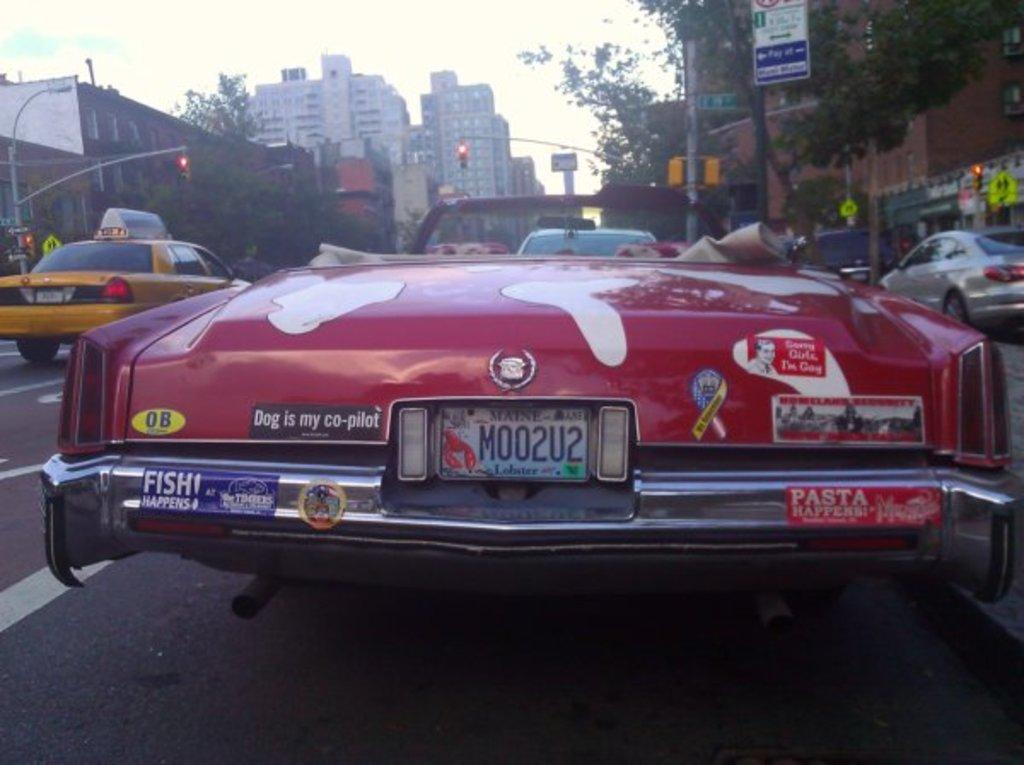<image>
Present a compact description of the photo's key features. The back of a red cadilac with several bumper stickers with one reading as dog is my co pilot. 